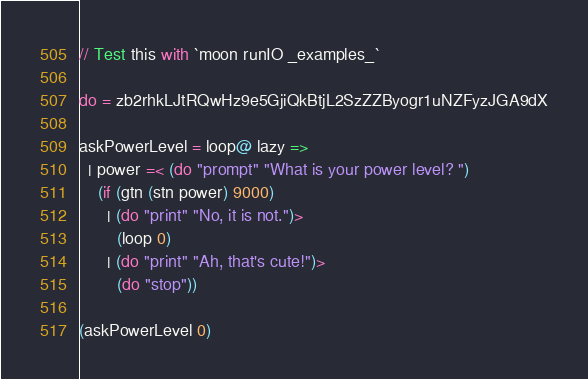<code> <loc_0><loc_0><loc_500><loc_500><_MoonScript_>// Test this with `moon runIO _examples_`

do = zb2rhkLJtRQwHz9e5GjiQkBtjL2SzZZByogr1uNZFyzJGA9dX

askPowerLevel = loop@ lazy =>
  | power =< (do "prompt" "What is your power level? ")
    (if (gtn (stn power) 9000)
      | (do "print" "No, it is not.")>
        (loop 0)
      | (do "print" "Ah, that's cute!")>
        (do "stop"))

(askPowerLevel 0)
</code> 